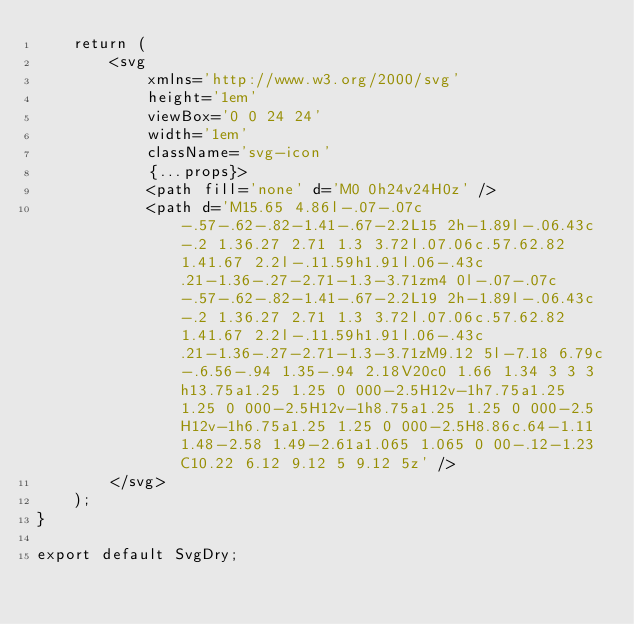<code> <loc_0><loc_0><loc_500><loc_500><_JavaScript_>	return (
		<svg
			xmlns='http://www.w3.org/2000/svg'
			height='1em'
			viewBox='0 0 24 24'
			width='1em'
			className='svg-icon'
			{...props}>
			<path fill='none' d='M0 0h24v24H0z' />
			<path d='M15.65 4.86l-.07-.07c-.57-.62-.82-1.41-.67-2.2L15 2h-1.89l-.06.43c-.2 1.36.27 2.71 1.3 3.72l.07.06c.57.62.82 1.41.67 2.2l-.11.59h1.91l.06-.43c.21-1.36-.27-2.71-1.3-3.71zm4 0l-.07-.07c-.57-.62-.82-1.41-.67-2.2L19 2h-1.89l-.06.43c-.2 1.36.27 2.71 1.3 3.72l.07.06c.57.62.82 1.41.67 2.2l-.11.59h1.91l.06-.43c.21-1.36-.27-2.71-1.3-3.71zM9.12 5l-7.18 6.79c-.6.56-.94 1.35-.94 2.18V20c0 1.66 1.34 3 3 3h13.75a1.25 1.25 0 000-2.5H12v-1h7.75a1.25 1.25 0 000-2.5H12v-1h8.75a1.25 1.25 0 000-2.5H12v-1h6.75a1.25 1.25 0 000-2.5H8.86c.64-1.11 1.48-2.58 1.49-2.61a1.065 1.065 0 00-.12-1.23C10.22 6.12 9.12 5 9.12 5z' />
		</svg>
	);
}

export default SvgDry;
</code> 